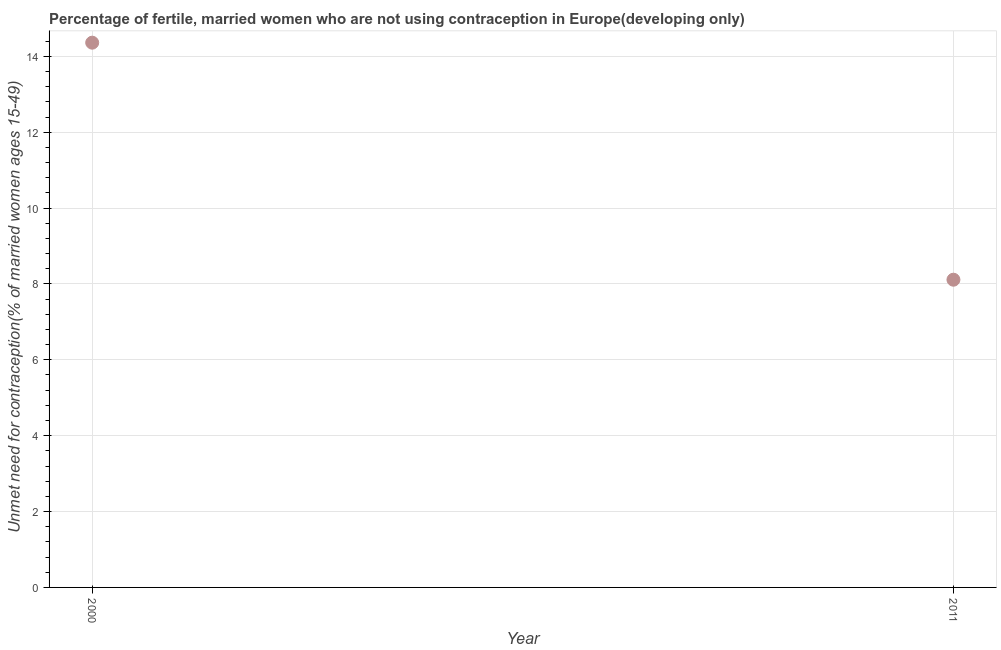What is the number of married women who are not using contraception in 2000?
Offer a terse response. 14.36. Across all years, what is the maximum number of married women who are not using contraception?
Offer a terse response. 14.36. Across all years, what is the minimum number of married women who are not using contraception?
Give a very brief answer. 8.11. In which year was the number of married women who are not using contraception minimum?
Keep it short and to the point. 2011. What is the sum of the number of married women who are not using contraception?
Your answer should be very brief. 22.47. What is the difference between the number of married women who are not using contraception in 2000 and 2011?
Your response must be concise. 6.25. What is the average number of married women who are not using contraception per year?
Your response must be concise. 11.24. What is the median number of married women who are not using contraception?
Give a very brief answer. 11.24. What is the ratio of the number of married women who are not using contraception in 2000 to that in 2011?
Ensure brevity in your answer.  1.77. Does the number of married women who are not using contraception monotonically increase over the years?
Provide a succinct answer. No. How many years are there in the graph?
Give a very brief answer. 2. What is the difference between two consecutive major ticks on the Y-axis?
Give a very brief answer. 2. Does the graph contain any zero values?
Your answer should be very brief. No. Does the graph contain grids?
Keep it short and to the point. Yes. What is the title of the graph?
Your response must be concise. Percentage of fertile, married women who are not using contraception in Europe(developing only). What is the label or title of the Y-axis?
Make the answer very short.  Unmet need for contraception(% of married women ages 15-49). What is the  Unmet need for contraception(% of married women ages 15-49) in 2000?
Your answer should be very brief. 14.36. What is the  Unmet need for contraception(% of married women ages 15-49) in 2011?
Keep it short and to the point. 8.11. What is the difference between the  Unmet need for contraception(% of married women ages 15-49) in 2000 and 2011?
Give a very brief answer. 6.25. What is the ratio of the  Unmet need for contraception(% of married women ages 15-49) in 2000 to that in 2011?
Your response must be concise. 1.77. 